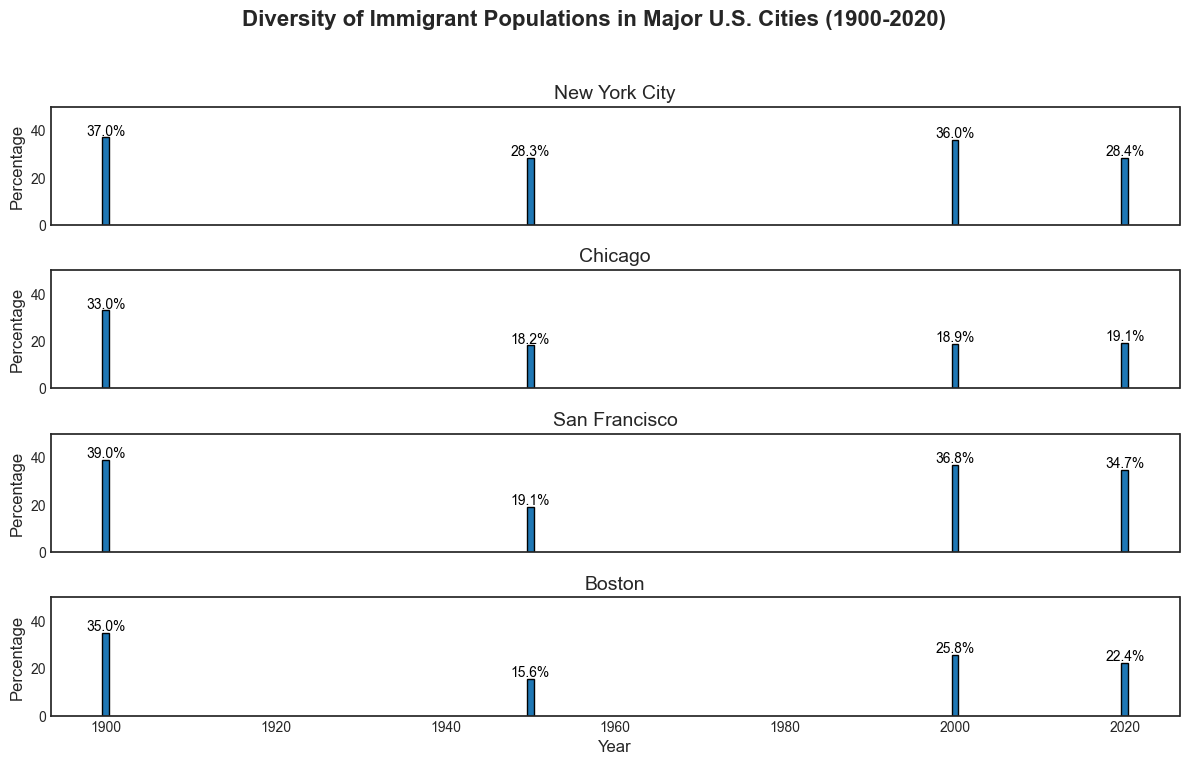What is the percentage difference in the immigrant population between New York City and Chicago in 1900? In 1900, New York City's immigrant population percentage is 37.0%, and Chicago's is 33.0%. The difference is 37.0% - 33.0% = 4.0%.
Answer: 4.0% Which city saw the highest immigrant population percentage in 2000? In 2000, New York City had 36.0%, Chicago had 18.9%, San Francisco had 36.8%, and Boston had 25.8%. San Francisco had the highest percentage at 36.8%.
Answer: San Francisco How did the immigrant population percentage change in Boston from 1900 to 2020? In 1900, Boston had an immigrant population percentage of 35.0%. In 2020, it decreased to 22.4%. The change is 35.0% - 22.4% = -12.6%.
Answer: -12.6% Between which years did New York City see a decrease in the immigrant population percentage? New York City's immigrant population percentage decreased between 1900 (37.0%) and 1950 (28.3%), and between 2000 (36.0%) and 2020 (28.4%).
Answer: 1900-1950, 2000-2020 Which city had the greatest increase in the immigrant population percentage from 1950 to 2000? From 1950 to 2000, New York City's percentage changed from 28.3% to 36.0%, Chicago's from 18.2% to 18.9%, San Francisco's from 19.1% to 36.8%, and Boston's from 15.6% to 25.8%. San Francisco had the greatest increase: 36.8% - 19.1% = 17.7%.
Answer: San Francisco How did the immigrant population percentage in Chicago compare in 1950 and 2020? In 1950, Chicago had an immigrant population percentage of 18.2%. In 2020, it was 19.1%. Comparing the two, it increased slightly by 19.1% - 18.2% = 0.9%.
Answer: 0.9% By how much did the immigrant population percentage in San Francisco drop between 2000 and 2020? In 2000, San Francisco had an immigrant population percentage of 36.8%. In 2020, it was 34.7%. The drop is calculated as 36.8% - 34.7% = 2.1%.
Answer: 2.1% What is the average immigrant population percentage in Boston over the years 1900, 1950, 2000, and 2020? The percentages in Boston were 35.0%, 15.6%, 25.8%, and 22.4%. The average is (35.0% + 15.6% + 25.8% + 22.4%) / 4 = 24.7%.
Answer: 24.7% Compare the immigrant population percentage in New York City in 1900 and 2020. Did it increase or decrease, and by how much? In 1900, New York City's percentage was 37.0%. In 2020, it was 28.4%. It decreased by 37.0% - 28.4% = 8.6%.
Answer: Decrease, 8.6% How does the immigrant population percentage in San Francisco in 1950 compare to Boston in 1900? In 1950, San Francisco's immigrant population percentage was 19.1%. In 1900, Boston's percentage was 35.0%. Boston's percentage was higher by 35.0% - 19.1% = 15.9%.
Answer: Boston was higher by 15.9% 